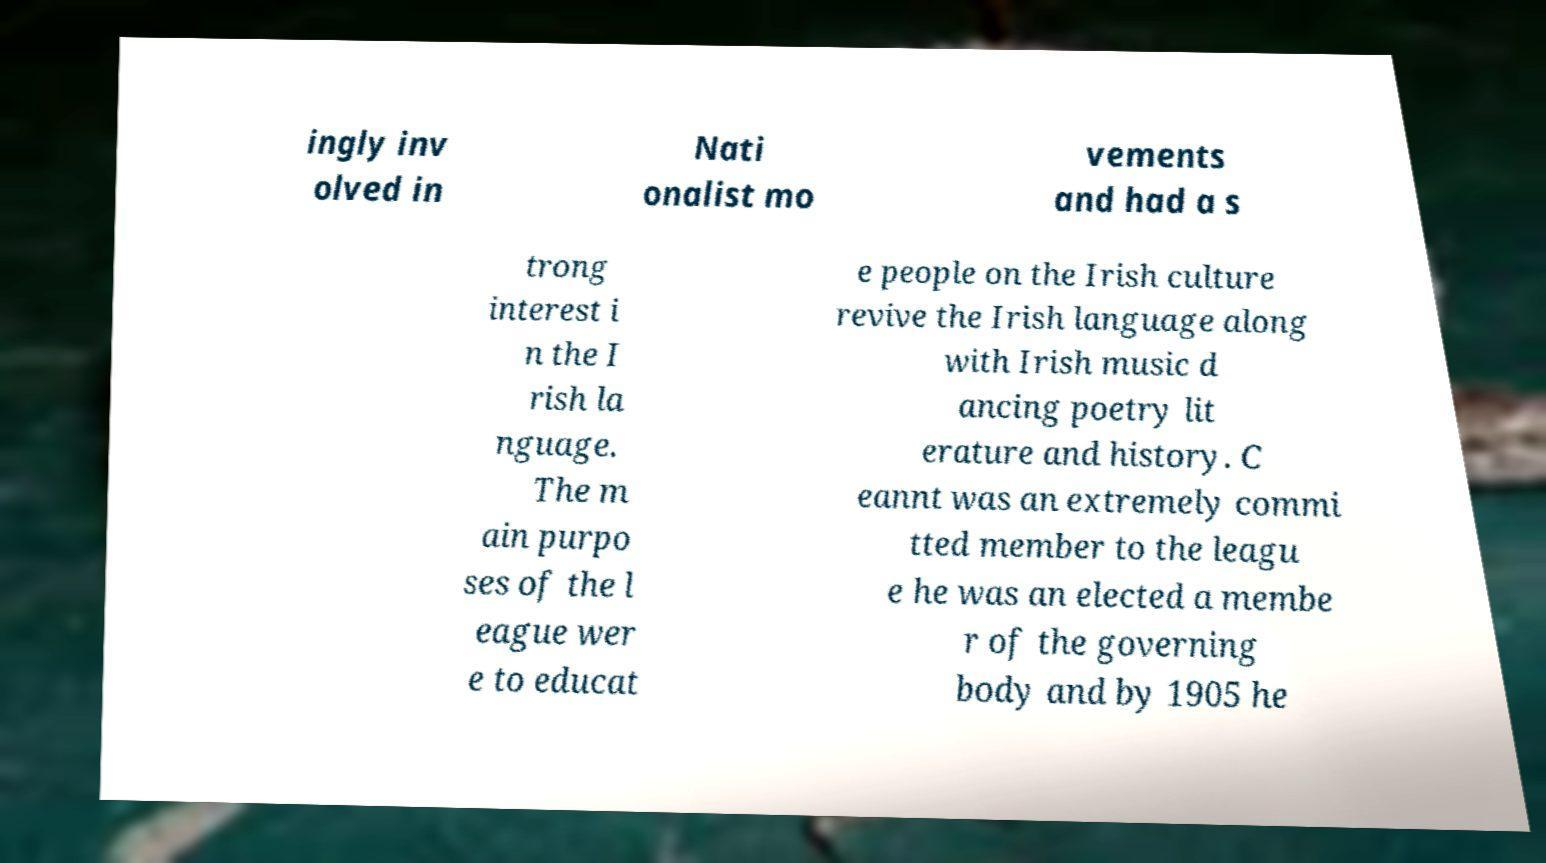Could you assist in decoding the text presented in this image and type it out clearly? ingly inv olved in Nati onalist mo vements and had a s trong interest i n the I rish la nguage. The m ain purpo ses of the l eague wer e to educat e people on the Irish culture revive the Irish language along with Irish music d ancing poetry lit erature and history. C eannt was an extremely commi tted member to the leagu e he was an elected a membe r of the governing body and by 1905 he 